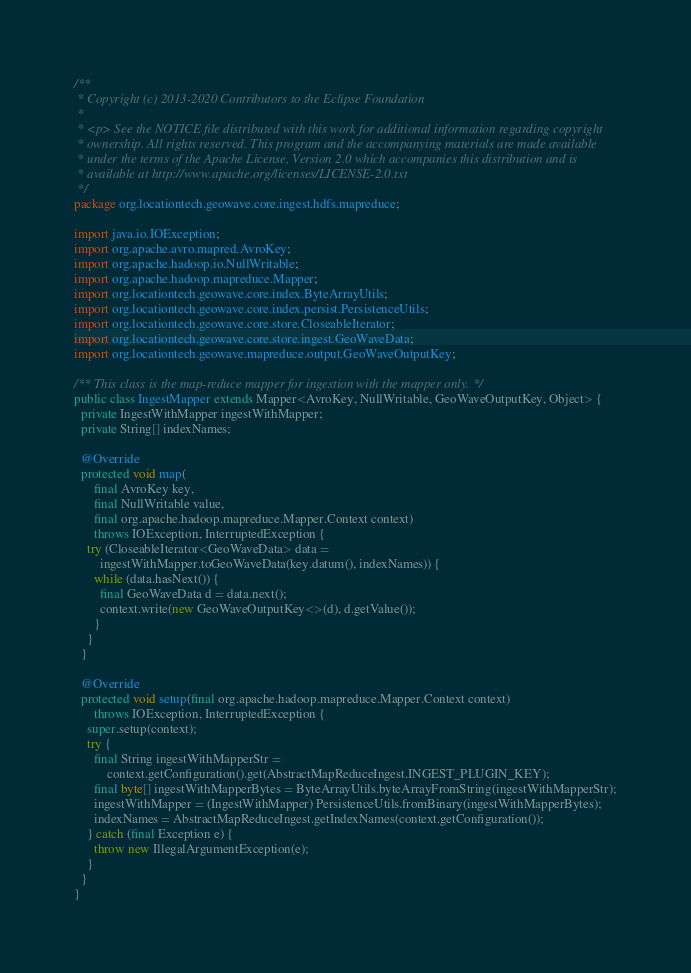<code> <loc_0><loc_0><loc_500><loc_500><_Java_>/**
 * Copyright (c) 2013-2020 Contributors to the Eclipse Foundation
 *
 * <p> See the NOTICE file distributed with this work for additional information regarding copyright
 * ownership. All rights reserved. This program and the accompanying materials are made available
 * under the terms of the Apache License, Version 2.0 which accompanies this distribution and is
 * available at http://www.apache.org/licenses/LICENSE-2.0.txt
 */
package org.locationtech.geowave.core.ingest.hdfs.mapreduce;

import java.io.IOException;
import org.apache.avro.mapred.AvroKey;
import org.apache.hadoop.io.NullWritable;
import org.apache.hadoop.mapreduce.Mapper;
import org.locationtech.geowave.core.index.ByteArrayUtils;
import org.locationtech.geowave.core.index.persist.PersistenceUtils;
import org.locationtech.geowave.core.store.CloseableIterator;
import org.locationtech.geowave.core.store.ingest.GeoWaveData;
import org.locationtech.geowave.mapreduce.output.GeoWaveOutputKey;

/** This class is the map-reduce mapper for ingestion with the mapper only. */
public class IngestMapper extends Mapper<AvroKey, NullWritable, GeoWaveOutputKey, Object> {
  private IngestWithMapper ingestWithMapper;
  private String[] indexNames;

  @Override
  protected void map(
      final AvroKey key,
      final NullWritable value,
      final org.apache.hadoop.mapreduce.Mapper.Context context)
      throws IOException, InterruptedException {
    try (CloseableIterator<GeoWaveData> data =
        ingestWithMapper.toGeoWaveData(key.datum(), indexNames)) {
      while (data.hasNext()) {
        final GeoWaveData d = data.next();
        context.write(new GeoWaveOutputKey<>(d), d.getValue());
      }
    }
  }

  @Override
  protected void setup(final org.apache.hadoop.mapreduce.Mapper.Context context)
      throws IOException, InterruptedException {
    super.setup(context);
    try {
      final String ingestWithMapperStr =
          context.getConfiguration().get(AbstractMapReduceIngest.INGEST_PLUGIN_KEY);
      final byte[] ingestWithMapperBytes = ByteArrayUtils.byteArrayFromString(ingestWithMapperStr);
      ingestWithMapper = (IngestWithMapper) PersistenceUtils.fromBinary(ingestWithMapperBytes);
      indexNames = AbstractMapReduceIngest.getIndexNames(context.getConfiguration());
    } catch (final Exception e) {
      throw new IllegalArgumentException(e);
    }
  }
}
</code> 